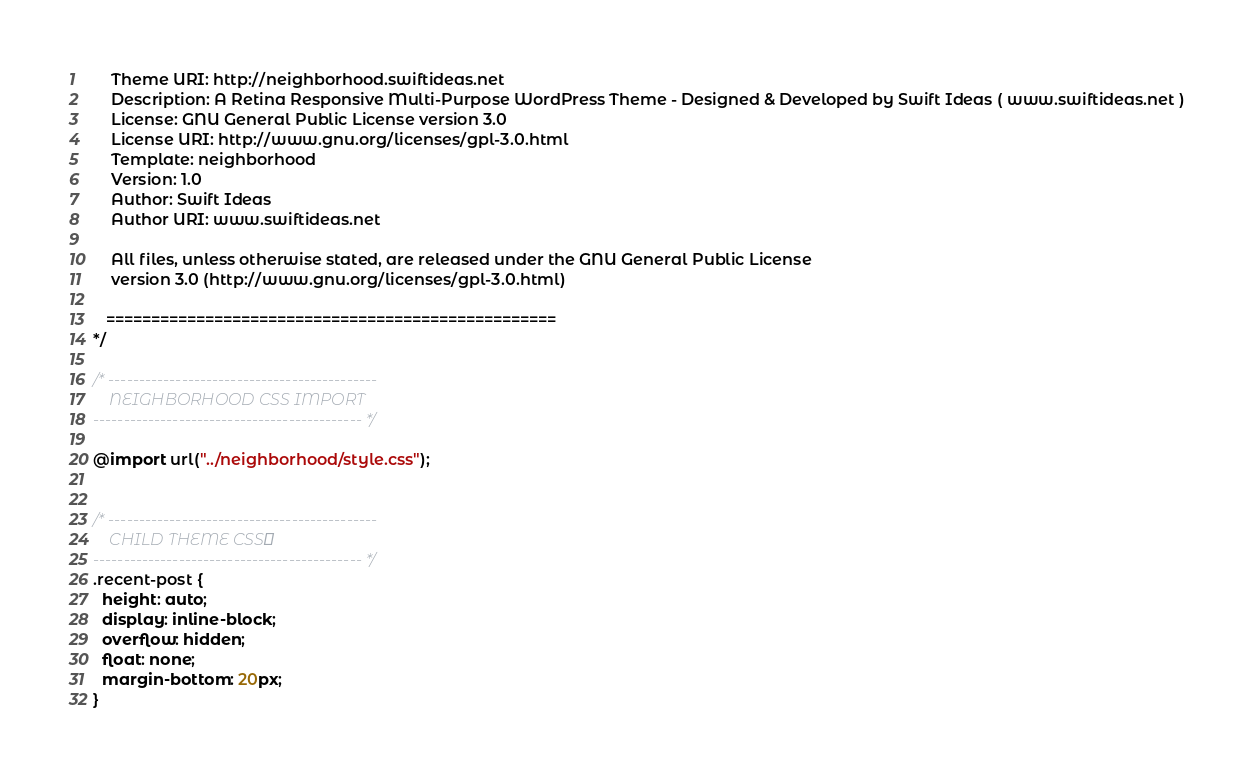Convert code to text. <code><loc_0><loc_0><loc_500><loc_500><_CSS_>	Theme URI: http://neighborhood.swiftideas.net
	Description: A Retina Responsive Multi-Purpose WordPress Theme - Designed & Developed by Swift Ideas ( www.swiftideas.net )
	License: GNU General Public License version 3.0
	License URI: http://www.gnu.org/licenses/gpl-3.0.html
	Template: neighborhood
	Version: 1.0
	Author: Swift Ideas
	Author URI: www.swiftideas.net

	All files, unless otherwise stated, are released under the GNU General Public License
	version 3.0 (http://www.gnu.org/licenses/gpl-3.0.html)

   ==================================================
*/

/* --------------------------------------------
	NEIGHBORHOOD CSS IMPORT
-------------------------------------------- */

@import url("../neighborhood/style.css");


/* --------------------------------------------
	CHILD THEME CSS
-------------------------------------------- */
.recent-post {
  height: auto;
  display: inline-block;
  overflow: hidden;
  float: none;
  margin-bottom: 20px;
}</code> 